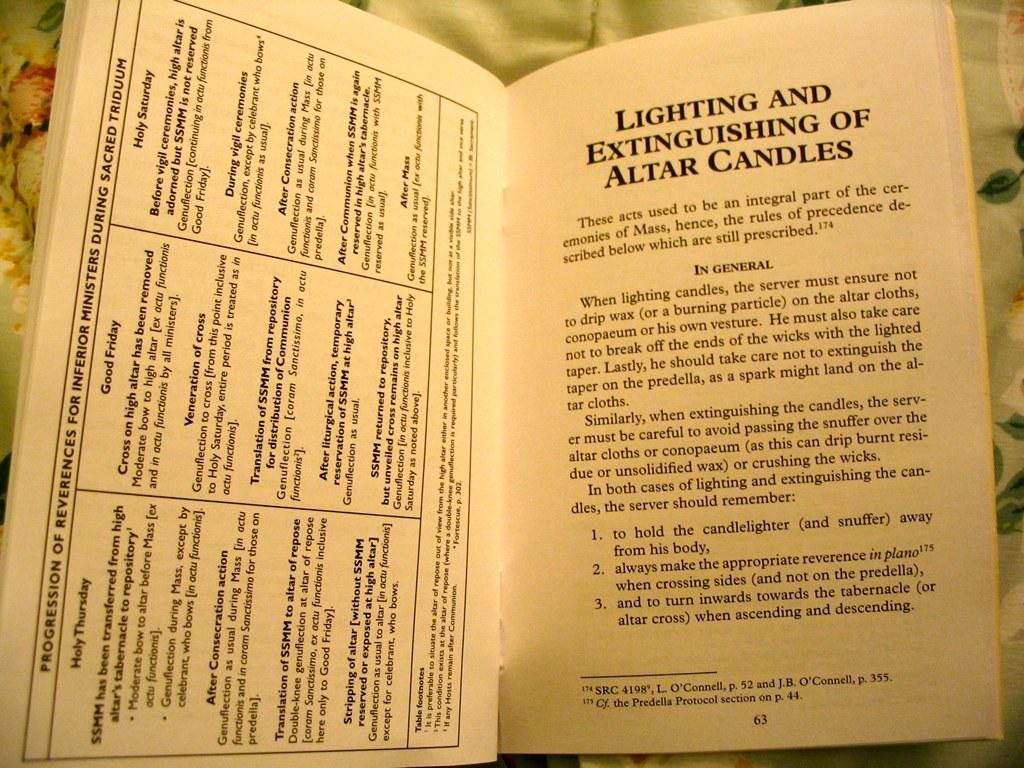<image>
Share a concise interpretation of the image provided. A open book on page 63 about Lighting and Extinguishing of Altar Candles. 